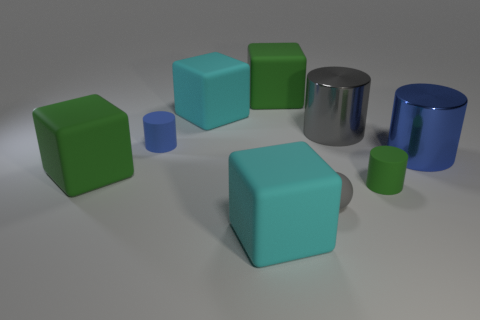Subtract all gray cylinders. How many cylinders are left? 3 Subtract all brown blocks. How many blue cylinders are left? 2 Subtract all gray cylinders. How many cylinders are left? 3 Subtract 1 blocks. How many blocks are left? 3 Add 5 small blue matte things. How many small blue matte things exist? 6 Subtract 0 blue spheres. How many objects are left? 9 Subtract all spheres. How many objects are left? 8 Subtract all red cylinders. Subtract all cyan balls. How many cylinders are left? 4 Subtract all green rubber blocks. Subtract all big cyan blocks. How many objects are left? 5 Add 2 large gray cylinders. How many large gray cylinders are left? 3 